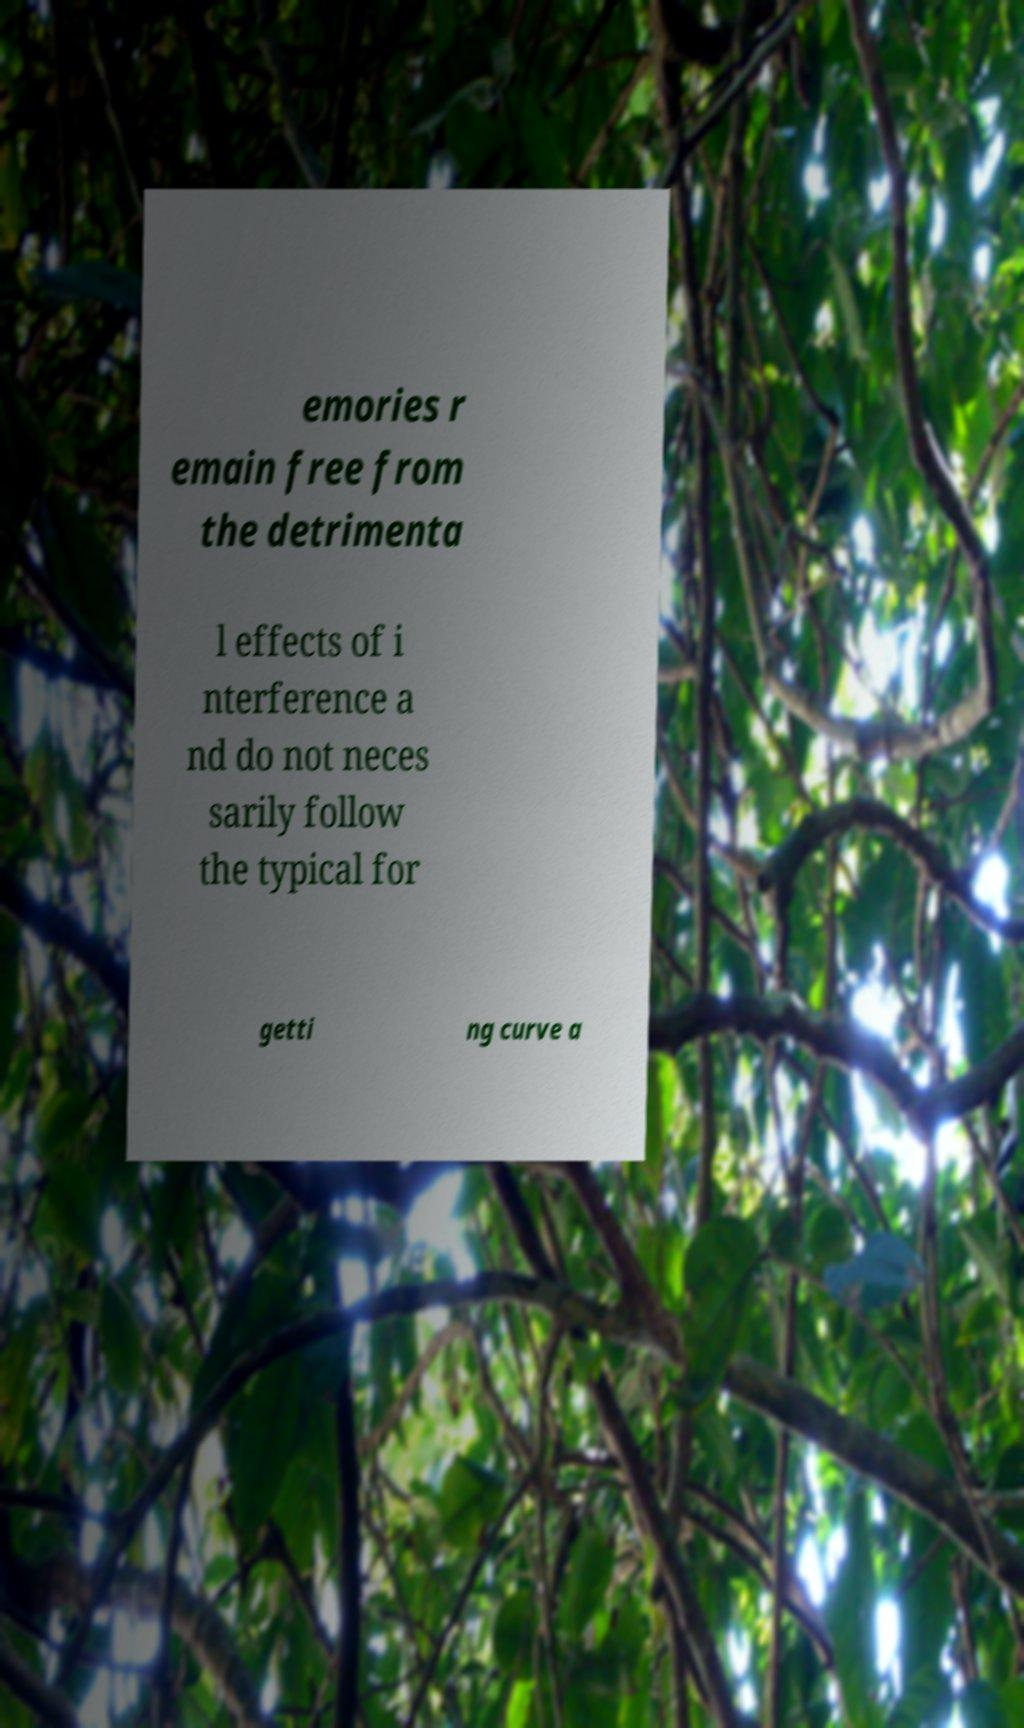Could you assist in decoding the text presented in this image and type it out clearly? emories r emain free from the detrimenta l effects of i nterference a nd do not neces sarily follow the typical for getti ng curve a 